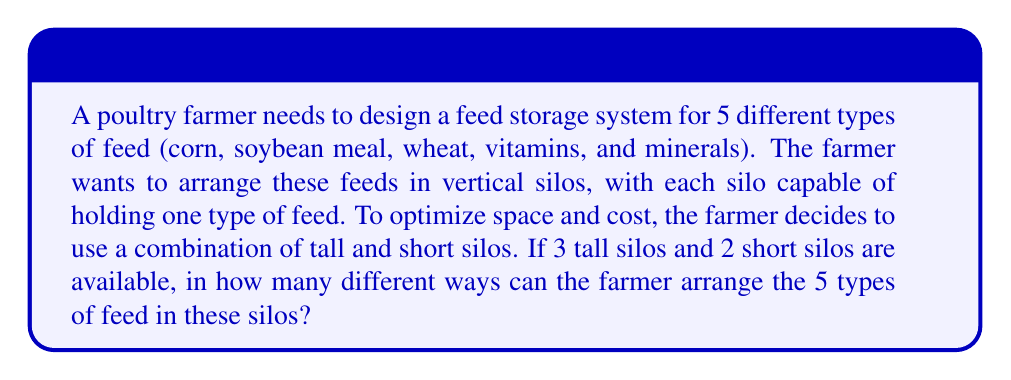Show me your answer to this math problem. To solve this problem, we'll use the concept of permutations with some constraints. Let's break it down step-by-step:

1) First, we need to consider that we have 5 types of feed and 5 silos (3 tall and 2 short).

2) This is a permutation problem because the order matters (each feed type in a specific silo).

3) However, we have two groups of silos (tall and short), which adds a constraint.

4) We can approach this problem by using the multiplication principle:
   (Ways to arrange feeds in tall silos) × (Ways to arrange remaining feeds in short silos)

5) For the tall silos:
   - We need to choose 3 out of 5 feed types to put in the tall silos.
   - This can be done in $\binom{5}{3}$ ways.
   - Once chosen, these 3 feeds can be arranged in 3! ways in the tall silos.

6) For the short silos:
   - The remaining 2 feed types will go into the short silos.
   - These can be arranged in 2! ways.

7) Putting it all together:
   $$\text{Total arrangements} = \binom{5}{3} \times 3! \times 2!$$

8) Let's calculate:
   $$\binom{5}{3} = \frac{5!}{3!(5-3)!} = \frac{5!}{3!2!} = 10$$
   $$10 \times 3! \times 2! = 10 \times 6 \times 2 = 120$$

Therefore, there are 120 different ways to arrange the 5 types of feed in the 5 silos.
Answer: 120 ways 